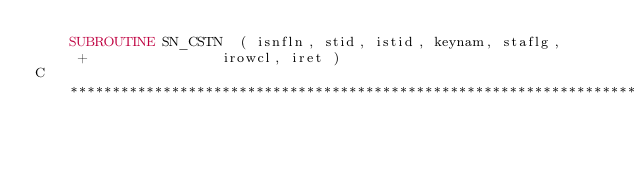Convert code to text. <code><loc_0><loc_0><loc_500><loc_500><_FORTRAN_>	SUBROUTINE SN_CSTN  ( isnfln, stid, istid, keynam, staflg, 
     +			      irowcl, iret )
C************************************************************************</code> 